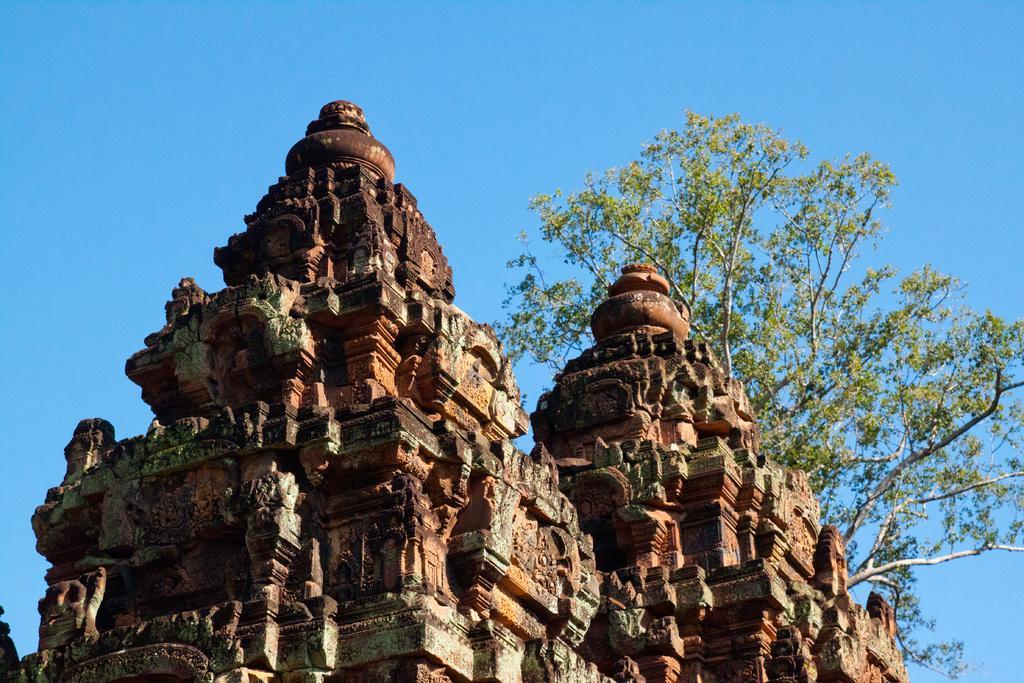Please provide a concise description of this image. In this image there are two temples having few sculptures on it. Behind the temple there is a tree. Top of the image there is sky. 